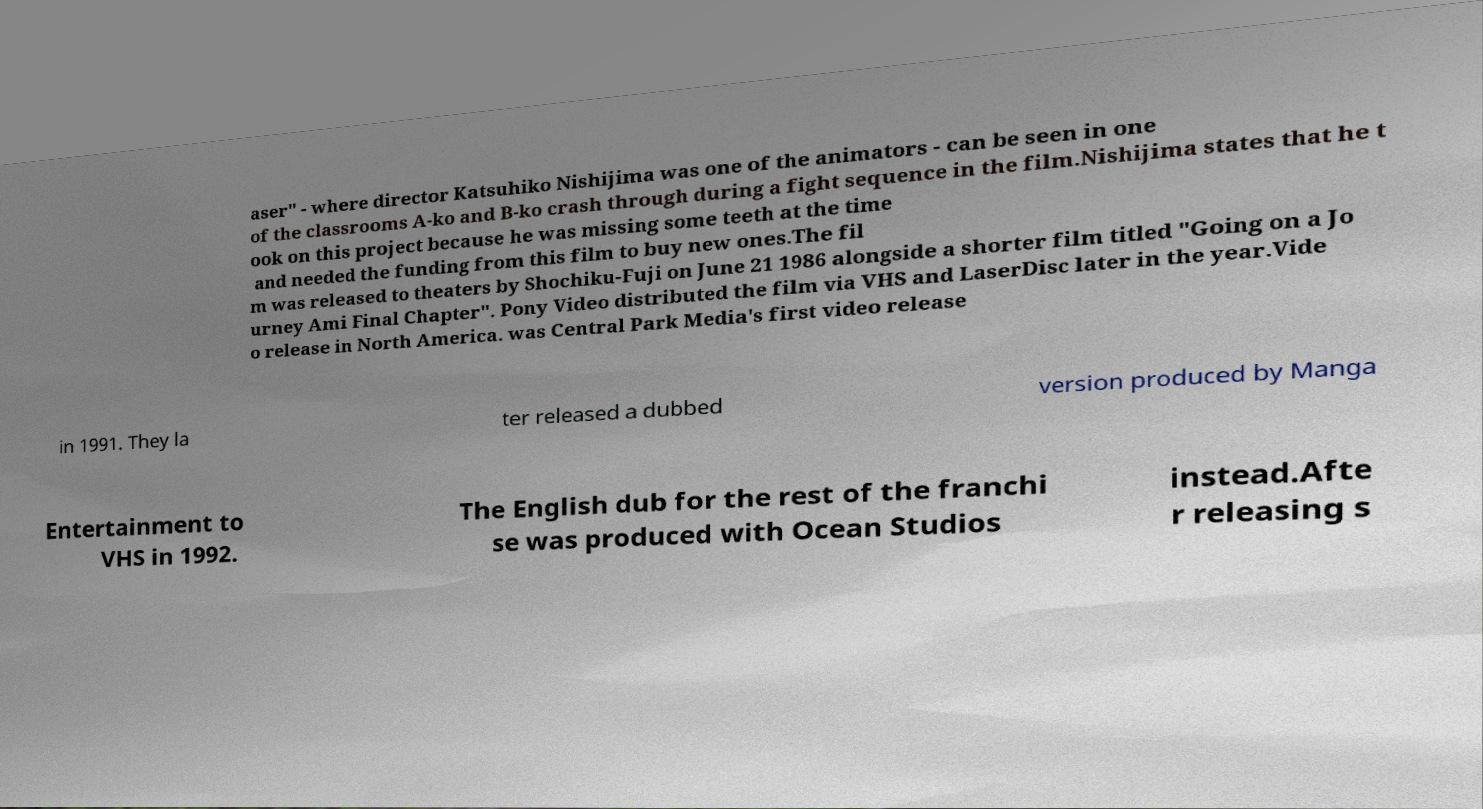Please read and relay the text visible in this image. What does it say? aser" - where director Katsuhiko Nishijima was one of the animators - can be seen in one of the classrooms A-ko and B-ko crash through during a fight sequence in the film.Nishijima states that he t ook on this project because he was missing some teeth at the time and needed the funding from this film to buy new ones.The fil m was released to theaters by Shochiku-Fuji on June 21 1986 alongside a shorter film titled "Going on a Jo urney Ami Final Chapter". Pony Video distributed the film via VHS and LaserDisc later in the year.Vide o release in North America. was Central Park Media's first video release in 1991. They la ter released a dubbed version produced by Manga Entertainment to VHS in 1992. The English dub for the rest of the franchi se was produced with Ocean Studios instead.Afte r releasing s 